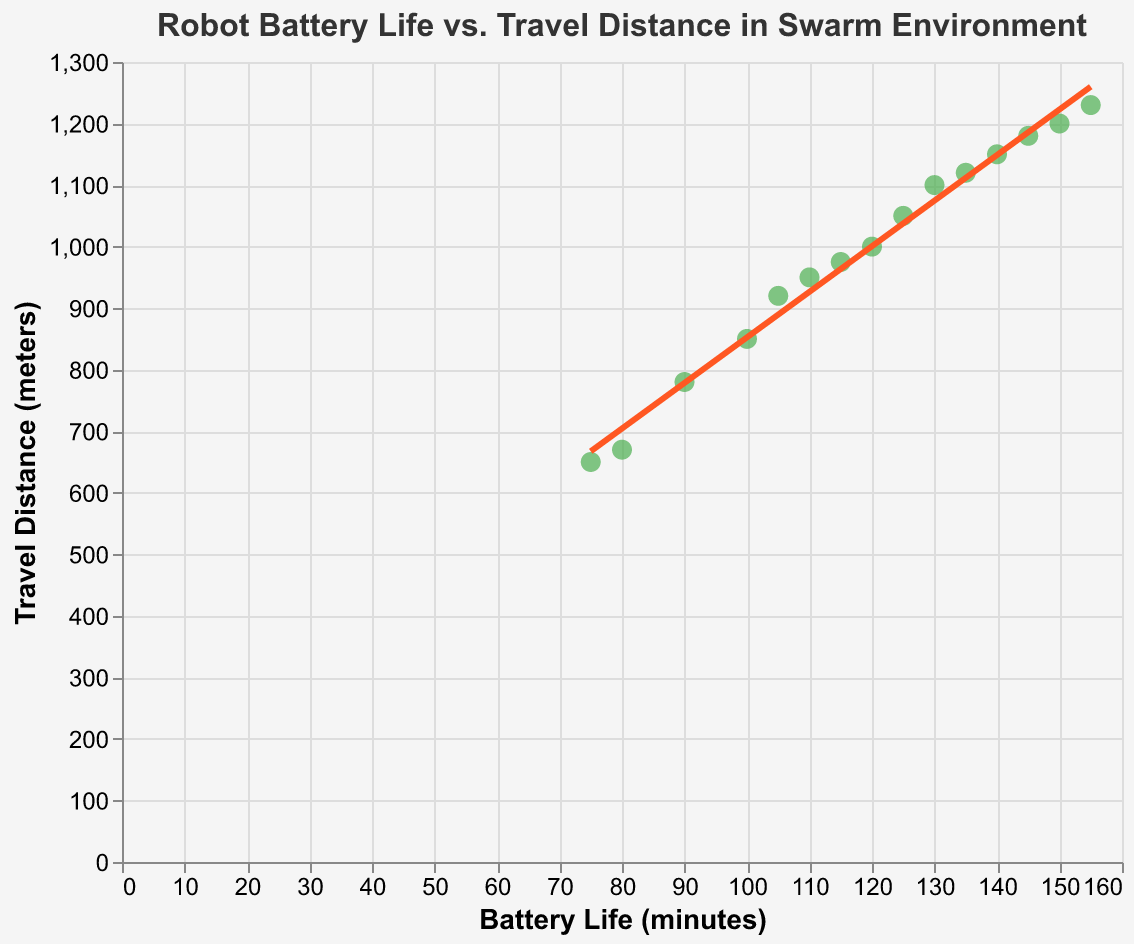How many data points are shown in the scatter plot? Count the number of points plotted on the scatter plot. There are 15 data points.
Answer: 15 What is the title of the scatter plot? Look at the title at the top of the scatter plot. The title is "Robot Battery Life vs. Travel Distance in Swarm Environment."
Answer: Robot Battery Life vs. Travel Distance in Swarm Environment Which robot has the highest battery life, and what is its travel distance? Identify the point with the largest value on the Battery Life (minutes) axis and find its corresponding Travel Distance (meters). The highest battery life is 155 minutes, and the travel distance is 1230 meters.
Answer: 155 minutes, 1230 meters How does the trend line behave with increasing battery life? Observe the direction and slope of the trend line. The trend line shows a positive slope, indicating that as battery life increases, travel distance also increases.
Answer: Increases positively Is there a robot with a travel distance of around 1000 meters, and what is its battery life? Find the point close to the 1000 meters mark on the Travel Distance axis and check its Battery Life. There's a point at 1000 meters with a battery life of 120 minutes.
Answer: 120 minutes Which robot has the shortest travel distance, and what is its battery life? Identify the point with the smallest value on the Travel Distance (meters) axis and find its corresponding Battery Life (minutes). The shortest travel distance is 650 meters, with a battery life of 75 minutes.
Answer: 650 meters, 75 minutes What is the difference in travel distance between robots with battery life 90 minutes and 150 minutes? Locate points for battery life 90 minutes (780 meters) and 150 minutes (1200 meters) and calculate the difference. The difference is 1200 - 780 = 420 meters.
Answer: 420 meters Compare the travel distance of robots with battery life 80 minutes and 105 minutes. Which one traveled further? Examine the points for battery life 80 minutes (670 meters) and 105 minutes (920 meters). The robot with 105 minutes battery life traveled further.
Answer: 105 minutes What is the average travel distance for robots with battery life less than 100 minutes? Average the travel distances for battery lives 100, 90, 80, and 75 minutes (850, 780, 670, 650). (850 + 780 + 670 + 650) / 4 = 737.5 meters.
Answer: 737.5 meters What color is used for the trend line, and what does it signify? Look at the color of the trend line, which is orange (#FF5722). The trend line indicates the general relationship between battery life and travel distance, showing a positive correlation.
Answer: Orange, positive correlation 